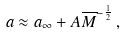Convert formula to latex. <formula><loc_0><loc_0><loc_500><loc_500>a \approx a _ { \infty } + A \overline { M } ^ { - \frac { 1 } { 2 } } \, ,</formula> 